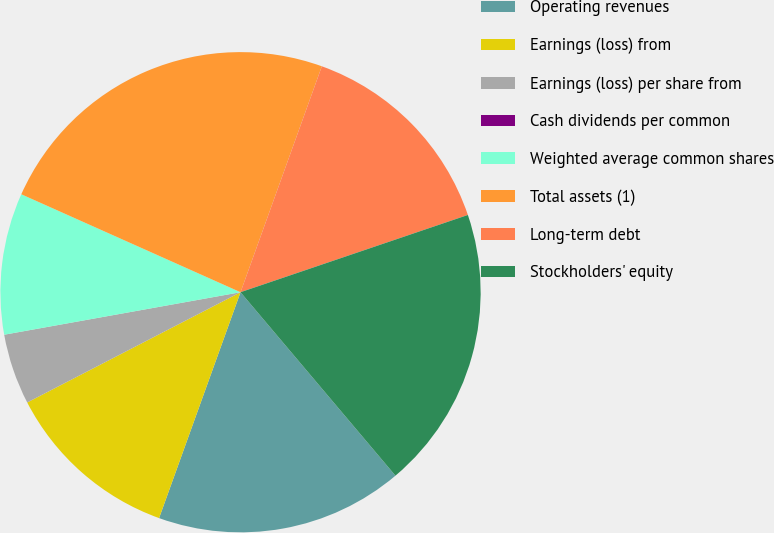Convert chart. <chart><loc_0><loc_0><loc_500><loc_500><pie_chart><fcel>Operating revenues<fcel>Earnings (loss) from<fcel>Earnings (loss) per share from<fcel>Cash dividends per common<fcel>Weighted average common shares<fcel>Total assets (1)<fcel>Long-term debt<fcel>Stockholders' equity<nl><fcel>16.67%<fcel>11.9%<fcel>4.76%<fcel>0.0%<fcel>9.52%<fcel>23.81%<fcel>14.29%<fcel>19.05%<nl></chart> 